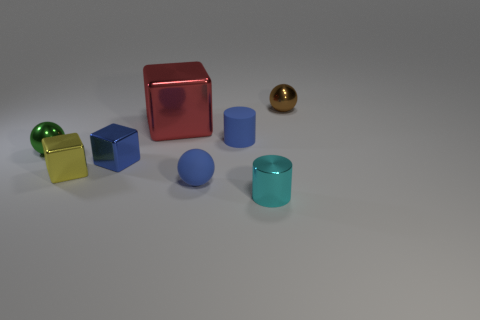Add 1 blue matte cylinders. How many objects exist? 9 Subtract all spheres. How many objects are left? 5 Add 7 large shiny objects. How many large shiny objects exist? 8 Subtract 0 brown cubes. How many objects are left? 8 Subtract all blue things. Subtract all cyan cylinders. How many objects are left? 4 Add 2 rubber objects. How many rubber objects are left? 4 